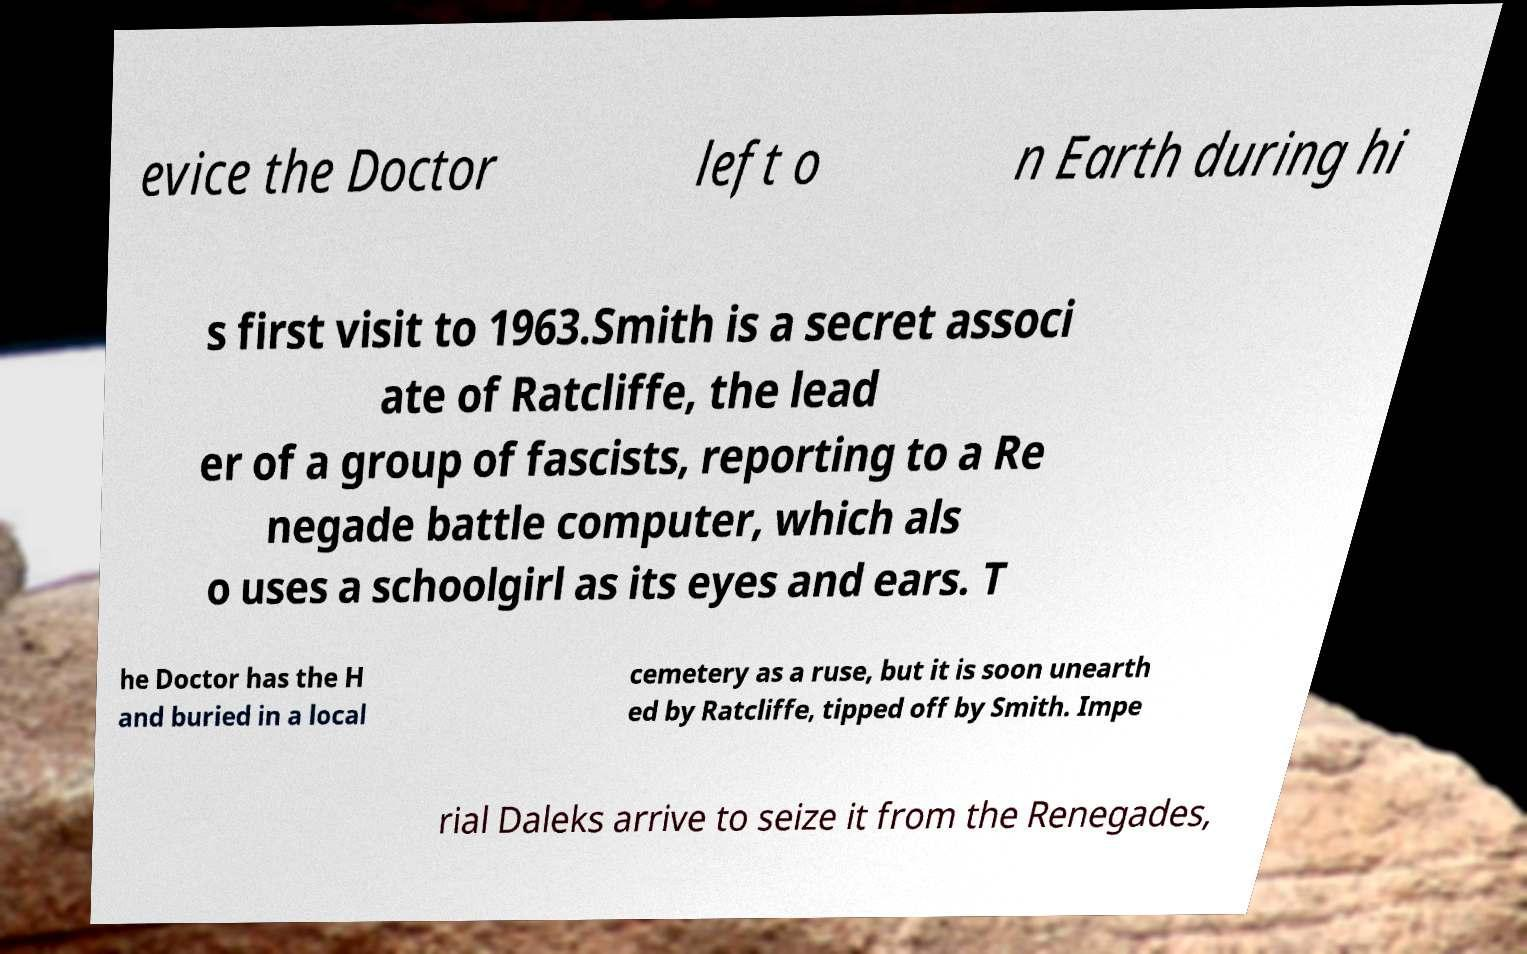I need the written content from this picture converted into text. Can you do that? evice the Doctor left o n Earth during hi s first visit to 1963.Smith is a secret associ ate of Ratcliffe, the lead er of a group of fascists, reporting to a Re negade battle computer, which als o uses a schoolgirl as its eyes and ears. T he Doctor has the H and buried in a local cemetery as a ruse, but it is soon unearth ed by Ratcliffe, tipped off by Smith. Impe rial Daleks arrive to seize it from the Renegades, 